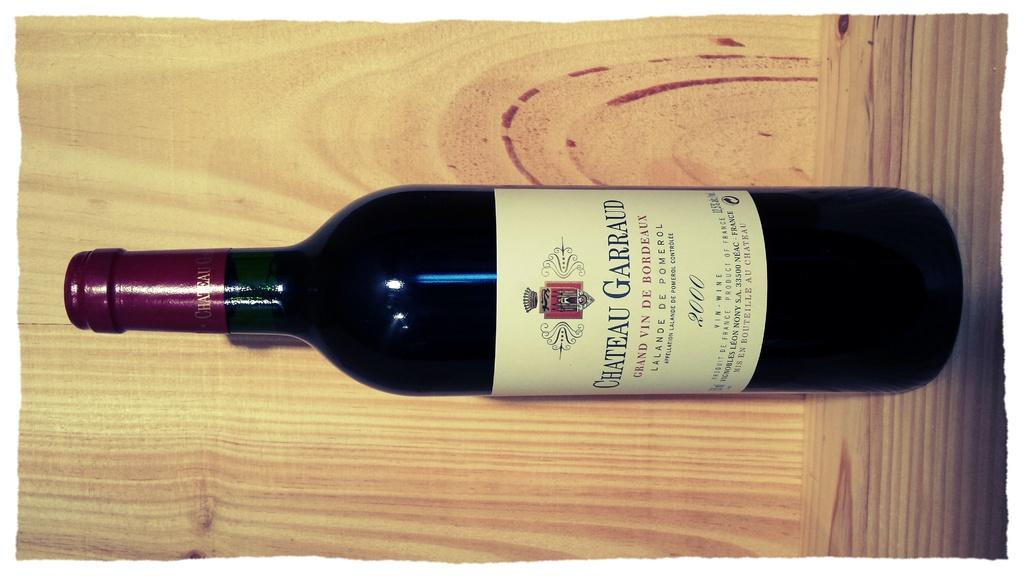<image>
Present a compact description of the photo's key features. A maroon bottle of Chateau Garraud wine is displayed against a wood background. 